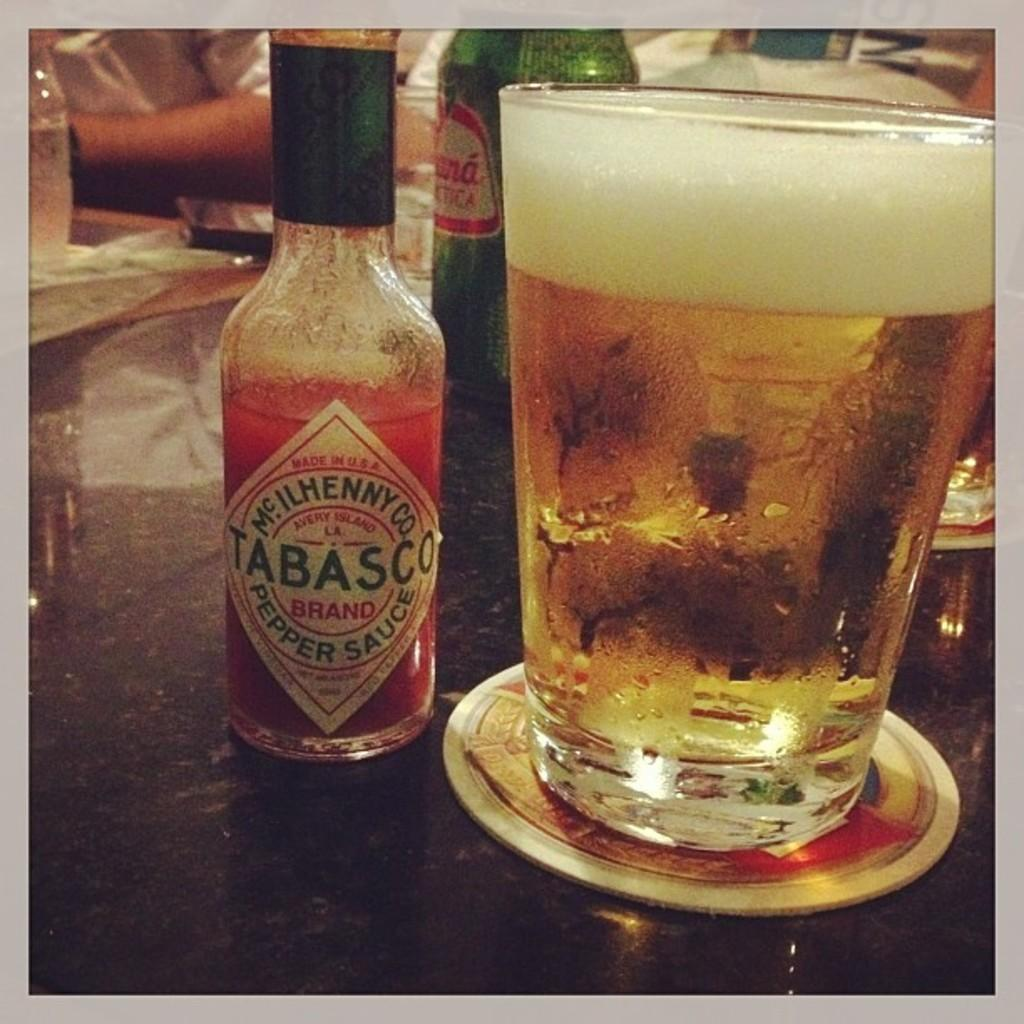Provide a one-sentence caption for the provided image. A bottle of Tabasco sauce is on a table next to a glass of beer. 